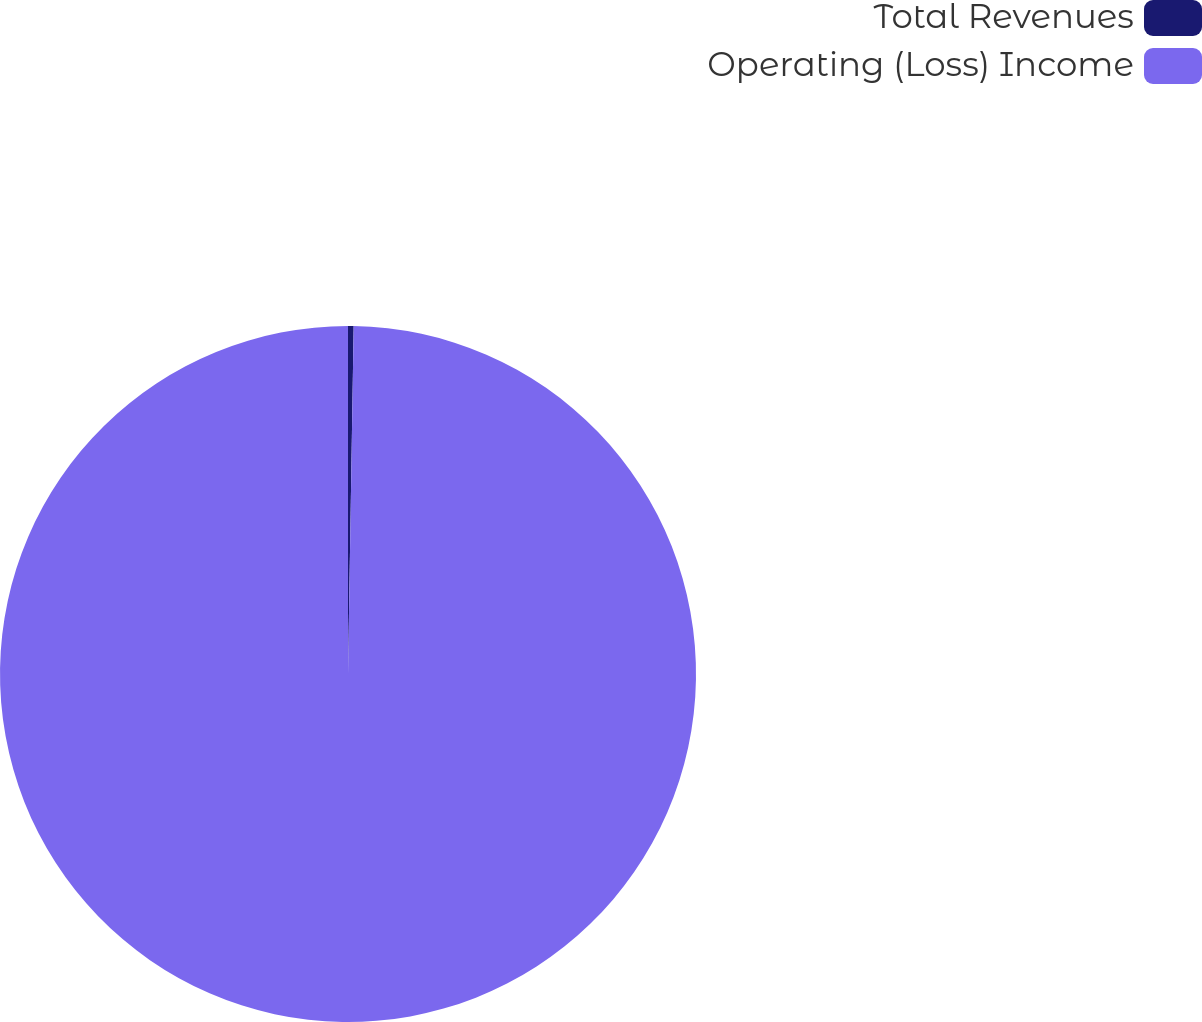Convert chart to OTSL. <chart><loc_0><loc_0><loc_500><loc_500><pie_chart><fcel>Total Revenues<fcel>Operating (Loss) Income<nl><fcel>0.26%<fcel>99.74%<nl></chart> 